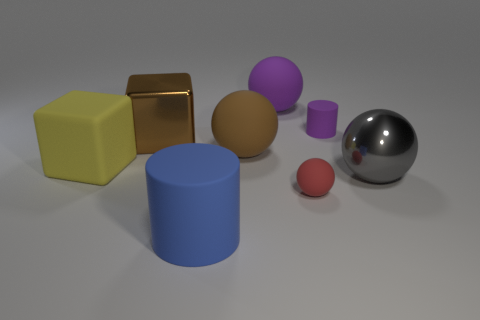Add 1 purple balls. How many objects exist? 9 Subtract all cubes. How many objects are left? 6 Add 6 purple rubber spheres. How many purple rubber spheres are left? 7 Add 1 small gray metal cubes. How many small gray metal cubes exist? 1 Subtract 0 yellow balls. How many objects are left? 8 Subtract all spheres. Subtract all big brown rubber objects. How many objects are left? 3 